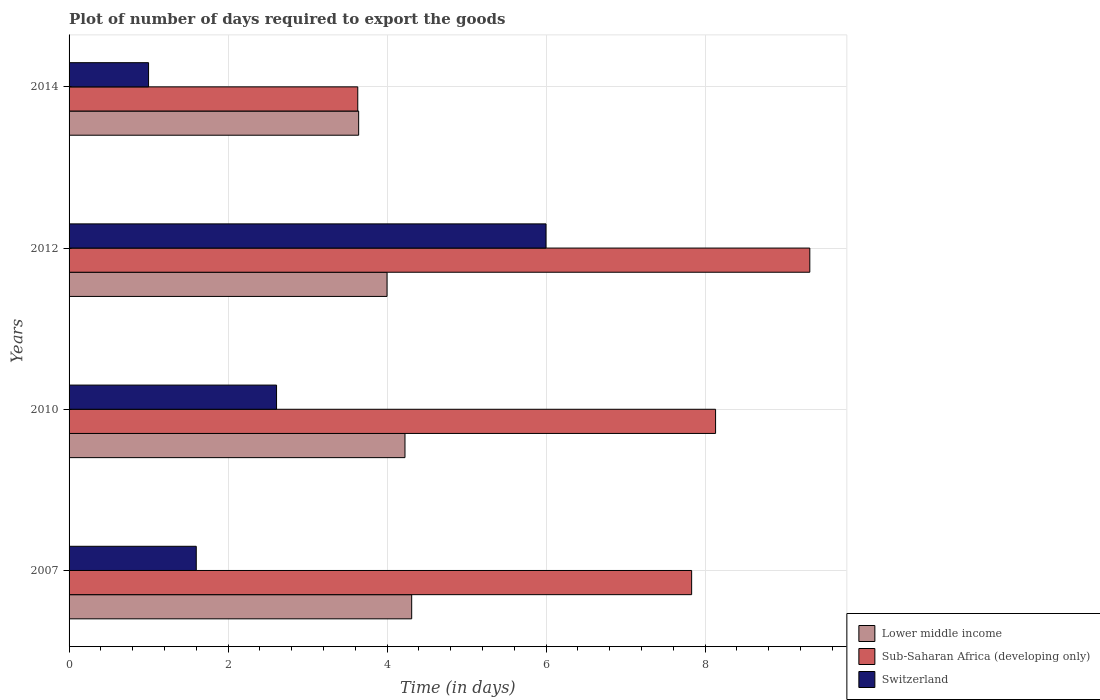How many different coloured bars are there?
Offer a terse response. 3. Are the number of bars on each tick of the Y-axis equal?
Keep it short and to the point. Yes. How many bars are there on the 2nd tick from the top?
Make the answer very short. 3. How many bars are there on the 2nd tick from the bottom?
Your answer should be very brief. 3. What is the time required to export goods in Lower middle income in 2007?
Your answer should be very brief. 4.31. Across all years, what is the maximum time required to export goods in Lower middle income?
Your response must be concise. 4.31. Across all years, what is the minimum time required to export goods in Sub-Saharan Africa (developing only)?
Your answer should be compact. 3.63. In which year was the time required to export goods in Lower middle income minimum?
Your response must be concise. 2014. What is the total time required to export goods in Sub-Saharan Africa (developing only) in the graph?
Provide a short and direct response. 28.91. What is the difference between the time required to export goods in Switzerland in 2007 and that in 2014?
Provide a succinct answer. 0.6. What is the difference between the time required to export goods in Switzerland in 2010 and the time required to export goods in Sub-Saharan Africa (developing only) in 2007?
Provide a succinct answer. -5.22. What is the average time required to export goods in Lower middle income per year?
Ensure brevity in your answer.  4.04. In the year 2014, what is the difference between the time required to export goods in Lower middle income and time required to export goods in Sub-Saharan Africa (developing only)?
Your answer should be very brief. 0.01. Is the time required to export goods in Sub-Saharan Africa (developing only) in 2007 less than that in 2014?
Provide a succinct answer. No. Is the difference between the time required to export goods in Lower middle income in 2007 and 2014 greater than the difference between the time required to export goods in Sub-Saharan Africa (developing only) in 2007 and 2014?
Provide a succinct answer. No. What is the difference between the highest and the second highest time required to export goods in Lower middle income?
Your response must be concise. 0.08. What is the difference between the highest and the lowest time required to export goods in Sub-Saharan Africa (developing only)?
Give a very brief answer. 5.69. In how many years, is the time required to export goods in Lower middle income greater than the average time required to export goods in Lower middle income taken over all years?
Offer a terse response. 2. What does the 2nd bar from the top in 2010 represents?
Your response must be concise. Sub-Saharan Africa (developing only). What does the 3rd bar from the bottom in 2012 represents?
Your answer should be very brief. Switzerland. How many bars are there?
Offer a terse response. 12. What is the difference between two consecutive major ticks on the X-axis?
Provide a short and direct response. 2. Are the values on the major ticks of X-axis written in scientific E-notation?
Make the answer very short. No. Does the graph contain grids?
Provide a succinct answer. Yes. How many legend labels are there?
Give a very brief answer. 3. How are the legend labels stacked?
Your answer should be very brief. Vertical. What is the title of the graph?
Provide a short and direct response. Plot of number of days required to export the goods. Does "United States" appear as one of the legend labels in the graph?
Offer a terse response. No. What is the label or title of the X-axis?
Provide a short and direct response. Time (in days). What is the Time (in days) of Lower middle income in 2007?
Give a very brief answer. 4.31. What is the Time (in days) of Sub-Saharan Africa (developing only) in 2007?
Your response must be concise. 7.83. What is the Time (in days) in Switzerland in 2007?
Provide a short and direct response. 1.6. What is the Time (in days) in Lower middle income in 2010?
Provide a short and direct response. 4.23. What is the Time (in days) in Sub-Saharan Africa (developing only) in 2010?
Keep it short and to the point. 8.13. What is the Time (in days) in Switzerland in 2010?
Make the answer very short. 2.61. What is the Time (in days) in Lower middle income in 2012?
Ensure brevity in your answer.  4. What is the Time (in days) in Sub-Saharan Africa (developing only) in 2012?
Your answer should be compact. 9.32. What is the Time (in days) in Lower middle income in 2014?
Ensure brevity in your answer.  3.64. What is the Time (in days) of Sub-Saharan Africa (developing only) in 2014?
Offer a very short reply. 3.63. What is the Time (in days) in Switzerland in 2014?
Your response must be concise. 1. Across all years, what is the maximum Time (in days) of Lower middle income?
Give a very brief answer. 4.31. Across all years, what is the maximum Time (in days) of Sub-Saharan Africa (developing only)?
Ensure brevity in your answer.  9.32. Across all years, what is the minimum Time (in days) in Lower middle income?
Keep it short and to the point. 3.64. Across all years, what is the minimum Time (in days) in Sub-Saharan Africa (developing only)?
Ensure brevity in your answer.  3.63. Across all years, what is the minimum Time (in days) in Switzerland?
Your response must be concise. 1. What is the total Time (in days) in Lower middle income in the graph?
Ensure brevity in your answer.  16.18. What is the total Time (in days) in Sub-Saharan Africa (developing only) in the graph?
Provide a succinct answer. 28.91. What is the total Time (in days) in Switzerland in the graph?
Offer a very short reply. 11.21. What is the difference between the Time (in days) of Lower middle income in 2007 and that in 2010?
Give a very brief answer. 0.08. What is the difference between the Time (in days) of Sub-Saharan Africa (developing only) in 2007 and that in 2010?
Provide a succinct answer. -0.3. What is the difference between the Time (in days) in Switzerland in 2007 and that in 2010?
Ensure brevity in your answer.  -1.01. What is the difference between the Time (in days) of Lower middle income in 2007 and that in 2012?
Provide a short and direct response. 0.31. What is the difference between the Time (in days) in Sub-Saharan Africa (developing only) in 2007 and that in 2012?
Provide a short and direct response. -1.49. What is the difference between the Time (in days) in Switzerland in 2007 and that in 2012?
Offer a terse response. -4.4. What is the difference between the Time (in days) of Lower middle income in 2007 and that in 2014?
Make the answer very short. 0.67. What is the difference between the Time (in days) of Lower middle income in 2010 and that in 2012?
Provide a succinct answer. 0.23. What is the difference between the Time (in days) of Sub-Saharan Africa (developing only) in 2010 and that in 2012?
Provide a succinct answer. -1.19. What is the difference between the Time (in days) in Switzerland in 2010 and that in 2012?
Your answer should be very brief. -3.39. What is the difference between the Time (in days) of Lower middle income in 2010 and that in 2014?
Give a very brief answer. 0.58. What is the difference between the Time (in days) in Sub-Saharan Africa (developing only) in 2010 and that in 2014?
Provide a succinct answer. 4.5. What is the difference between the Time (in days) of Switzerland in 2010 and that in 2014?
Offer a terse response. 1.61. What is the difference between the Time (in days) in Lower middle income in 2012 and that in 2014?
Ensure brevity in your answer.  0.36. What is the difference between the Time (in days) in Sub-Saharan Africa (developing only) in 2012 and that in 2014?
Ensure brevity in your answer.  5.69. What is the difference between the Time (in days) in Lower middle income in 2007 and the Time (in days) in Sub-Saharan Africa (developing only) in 2010?
Make the answer very short. -3.82. What is the difference between the Time (in days) of Sub-Saharan Africa (developing only) in 2007 and the Time (in days) of Switzerland in 2010?
Offer a very short reply. 5.22. What is the difference between the Time (in days) of Lower middle income in 2007 and the Time (in days) of Sub-Saharan Africa (developing only) in 2012?
Give a very brief answer. -5.01. What is the difference between the Time (in days) of Lower middle income in 2007 and the Time (in days) of Switzerland in 2012?
Your response must be concise. -1.69. What is the difference between the Time (in days) in Sub-Saharan Africa (developing only) in 2007 and the Time (in days) in Switzerland in 2012?
Give a very brief answer. 1.83. What is the difference between the Time (in days) in Lower middle income in 2007 and the Time (in days) in Sub-Saharan Africa (developing only) in 2014?
Keep it short and to the point. 0.68. What is the difference between the Time (in days) of Lower middle income in 2007 and the Time (in days) of Switzerland in 2014?
Keep it short and to the point. 3.31. What is the difference between the Time (in days) in Sub-Saharan Africa (developing only) in 2007 and the Time (in days) in Switzerland in 2014?
Your answer should be compact. 6.83. What is the difference between the Time (in days) in Lower middle income in 2010 and the Time (in days) in Sub-Saharan Africa (developing only) in 2012?
Provide a short and direct response. -5.09. What is the difference between the Time (in days) of Lower middle income in 2010 and the Time (in days) of Switzerland in 2012?
Offer a terse response. -1.77. What is the difference between the Time (in days) in Sub-Saharan Africa (developing only) in 2010 and the Time (in days) in Switzerland in 2012?
Your answer should be compact. 2.13. What is the difference between the Time (in days) in Lower middle income in 2010 and the Time (in days) in Sub-Saharan Africa (developing only) in 2014?
Give a very brief answer. 0.59. What is the difference between the Time (in days) in Lower middle income in 2010 and the Time (in days) in Switzerland in 2014?
Make the answer very short. 3.23. What is the difference between the Time (in days) of Sub-Saharan Africa (developing only) in 2010 and the Time (in days) of Switzerland in 2014?
Your response must be concise. 7.13. What is the difference between the Time (in days) in Lower middle income in 2012 and the Time (in days) in Sub-Saharan Africa (developing only) in 2014?
Ensure brevity in your answer.  0.37. What is the difference between the Time (in days) of Sub-Saharan Africa (developing only) in 2012 and the Time (in days) of Switzerland in 2014?
Your answer should be compact. 8.32. What is the average Time (in days) of Lower middle income per year?
Give a very brief answer. 4.04. What is the average Time (in days) of Sub-Saharan Africa (developing only) per year?
Keep it short and to the point. 7.23. What is the average Time (in days) in Switzerland per year?
Offer a terse response. 2.8. In the year 2007, what is the difference between the Time (in days) of Lower middle income and Time (in days) of Sub-Saharan Africa (developing only)?
Keep it short and to the point. -3.52. In the year 2007, what is the difference between the Time (in days) of Lower middle income and Time (in days) of Switzerland?
Keep it short and to the point. 2.71. In the year 2007, what is the difference between the Time (in days) in Sub-Saharan Africa (developing only) and Time (in days) in Switzerland?
Provide a short and direct response. 6.23. In the year 2010, what is the difference between the Time (in days) of Lower middle income and Time (in days) of Sub-Saharan Africa (developing only)?
Offer a very short reply. -3.91. In the year 2010, what is the difference between the Time (in days) of Lower middle income and Time (in days) of Switzerland?
Your answer should be very brief. 1.62. In the year 2010, what is the difference between the Time (in days) of Sub-Saharan Africa (developing only) and Time (in days) of Switzerland?
Ensure brevity in your answer.  5.52. In the year 2012, what is the difference between the Time (in days) of Lower middle income and Time (in days) of Sub-Saharan Africa (developing only)?
Provide a short and direct response. -5.32. In the year 2012, what is the difference between the Time (in days) in Lower middle income and Time (in days) in Switzerland?
Your answer should be very brief. -2. In the year 2012, what is the difference between the Time (in days) in Sub-Saharan Africa (developing only) and Time (in days) in Switzerland?
Your response must be concise. 3.32. In the year 2014, what is the difference between the Time (in days) of Lower middle income and Time (in days) of Sub-Saharan Africa (developing only)?
Keep it short and to the point. 0.01. In the year 2014, what is the difference between the Time (in days) of Lower middle income and Time (in days) of Switzerland?
Offer a terse response. 2.64. In the year 2014, what is the difference between the Time (in days) of Sub-Saharan Africa (developing only) and Time (in days) of Switzerland?
Your answer should be very brief. 2.63. What is the ratio of the Time (in days) of Lower middle income in 2007 to that in 2010?
Give a very brief answer. 1.02. What is the ratio of the Time (in days) of Sub-Saharan Africa (developing only) in 2007 to that in 2010?
Provide a short and direct response. 0.96. What is the ratio of the Time (in days) of Switzerland in 2007 to that in 2010?
Keep it short and to the point. 0.61. What is the ratio of the Time (in days) in Lower middle income in 2007 to that in 2012?
Offer a very short reply. 1.08. What is the ratio of the Time (in days) of Sub-Saharan Africa (developing only) in 2007 to that in 2012?
Give a very brief answer. 0.84. What is the ratio of the Time (in days) in Switzerland in 2007 to that in 2012?
Keep it short and to the point. 0.27. What is the ratio of the Time (in days) in Lower middle income in 2007 to that in 2014?
Offer a terse response. 1.18. What is the ratio of the Time (in days) of Sub-Saharan Africa (developing only) in 2007 to that in 2014?
Offer a terse response. 2.16. What is the ratio of the Time (in days) in Switzerland in 2007 to that in 2014?
Ensure brevity in your answer.  1.6. What is the ratio of the Time (in days) of Lower middle income in 2010 to that in 2012?
Give a very brief answer. 1.06. What is the ratio of the Time (in days) in Sub-Saharan Africa (developing only) in 2010 to that in 2012?
Provide a short and direct response. 0.87. What is the ratio of the Time (in days) of Switzerland in 2010 to that in 2012?
Offer a very short reply. 0.43. What is the ratio of the Time (in days) in Lower middle income in 2010 to that in 2014?
Your answer should be very brief. 1.16. What is the ratio of the Time (in days) in Sub-Saharan Africa (developing only) in 2010 to that in 2014?
Your answer should be compact. 2.24. What is the ratio of the Time (in days) in Switzerland in 2010 to that in 2014?
Your answer should be compact. 2.61. What is the ratio of the Time (in days) in Lower middle income in 2012 to that in 2014?
Give a very brief answer. 1.1. What is the ratio of the Time (in days) in Sub-Saharan Africa (developing only) in 2012 to that in 2014?
Give a very brief answer. 2.57. What is the ratio of the Time (in days) in Switzerland in 2012 to that in 2014?
Your answer should be very brief. 6. What is the difference between the highest and the second highest Time (in days) in Lower middle income?
Provide a short and direct response. 0.08. What is the difference between the highest and the second highest Time (in days) of Sub-Saharan Africa (developing only)?
Offer a very short reply. 1.19. What is the difference between the highest and the second highest Time (in days) of Switzerland?
Offer a very short reply. 3.39. What is the difference between the highest and the lowest Time (in days) of Lower middle income?
Offer a very short reply. 0.67. What is the difference between the highest and the lowest Time (in days) in Sub-Saharan Africa (developing only)?
Your response must be concise. 5.69. 